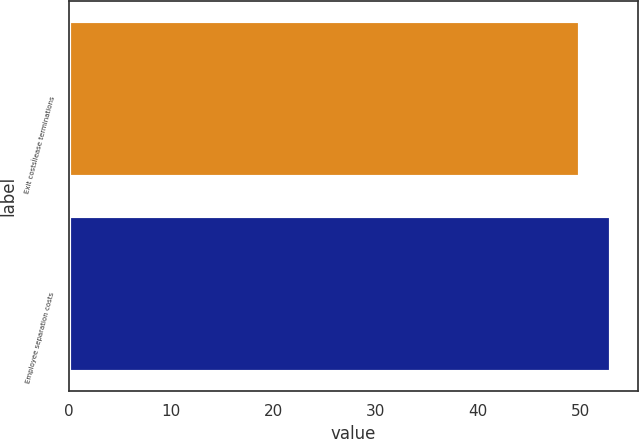Convert chart. <chart><loc_0><loc_0><loc_500><loc_500><bar_chart><fcel>Exit costsÌlease terminations<fcel>Employee separation costs<nl><fcel>50<fcel>53<nl></chart> 